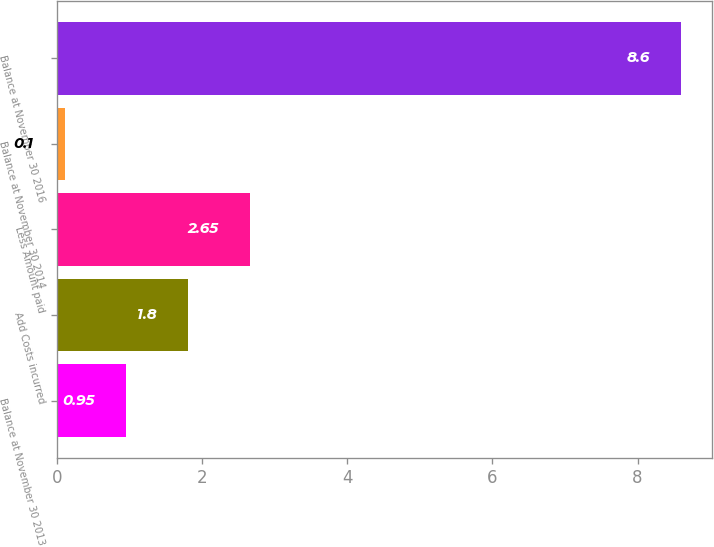<chart> <loc_0><loc_0><loc_500><loc_500><bar_chart><fcel>Balance at November 30 2013<fcel>Add Costs incurred<fcel>Less Amount paid<fcel>Balance at November 30 2014<fcel>Balance at November 30 2016<nl><fcel>0.95<fcel>1.8<fcel>2.65<fcel>0.1<fcel>8.6<nl></chart> 